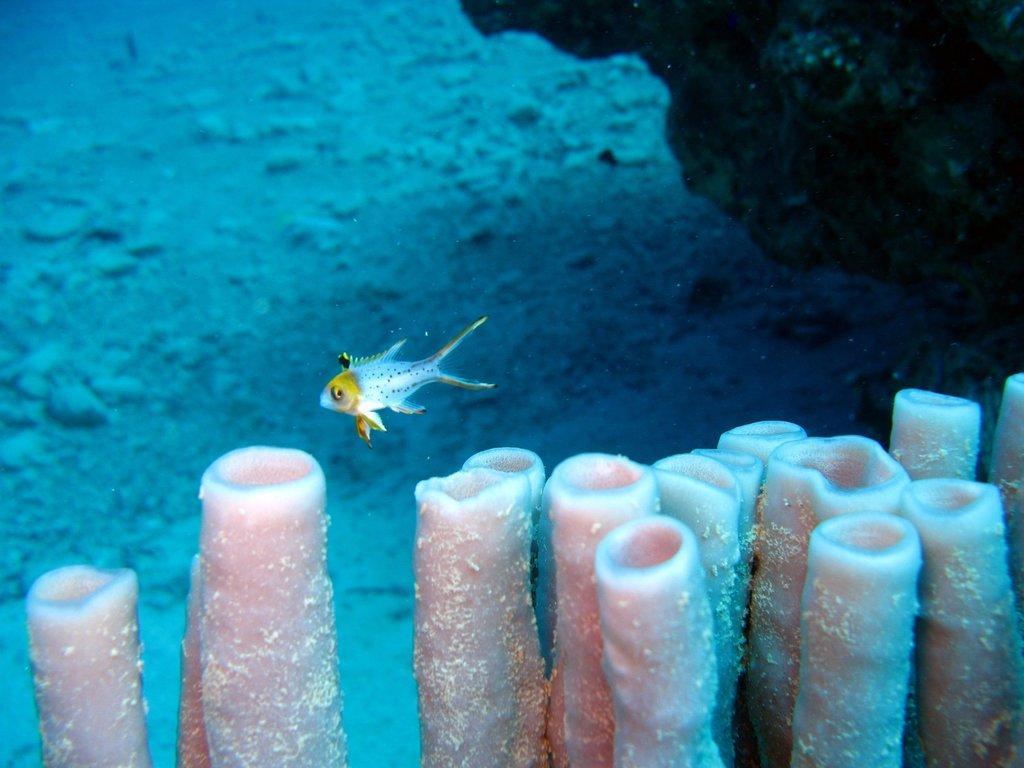Can you describe this image briefly? In this image we can see a fish in the water, at the bottom of the image it looks like some plants. 